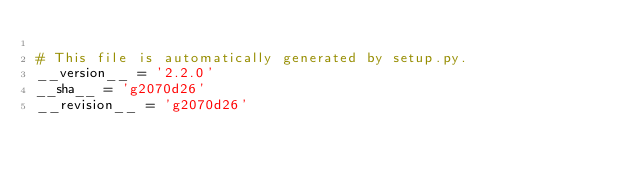Convert code to text. <code><loc_0><loc_0><loc_500><loc_500><_Python_>
# This file is automatically generated by setup.py.
__version__ = '2.2.0'
__sha__ = 'g2070d26'
__revision__ = 'g2070d26'
</code> 